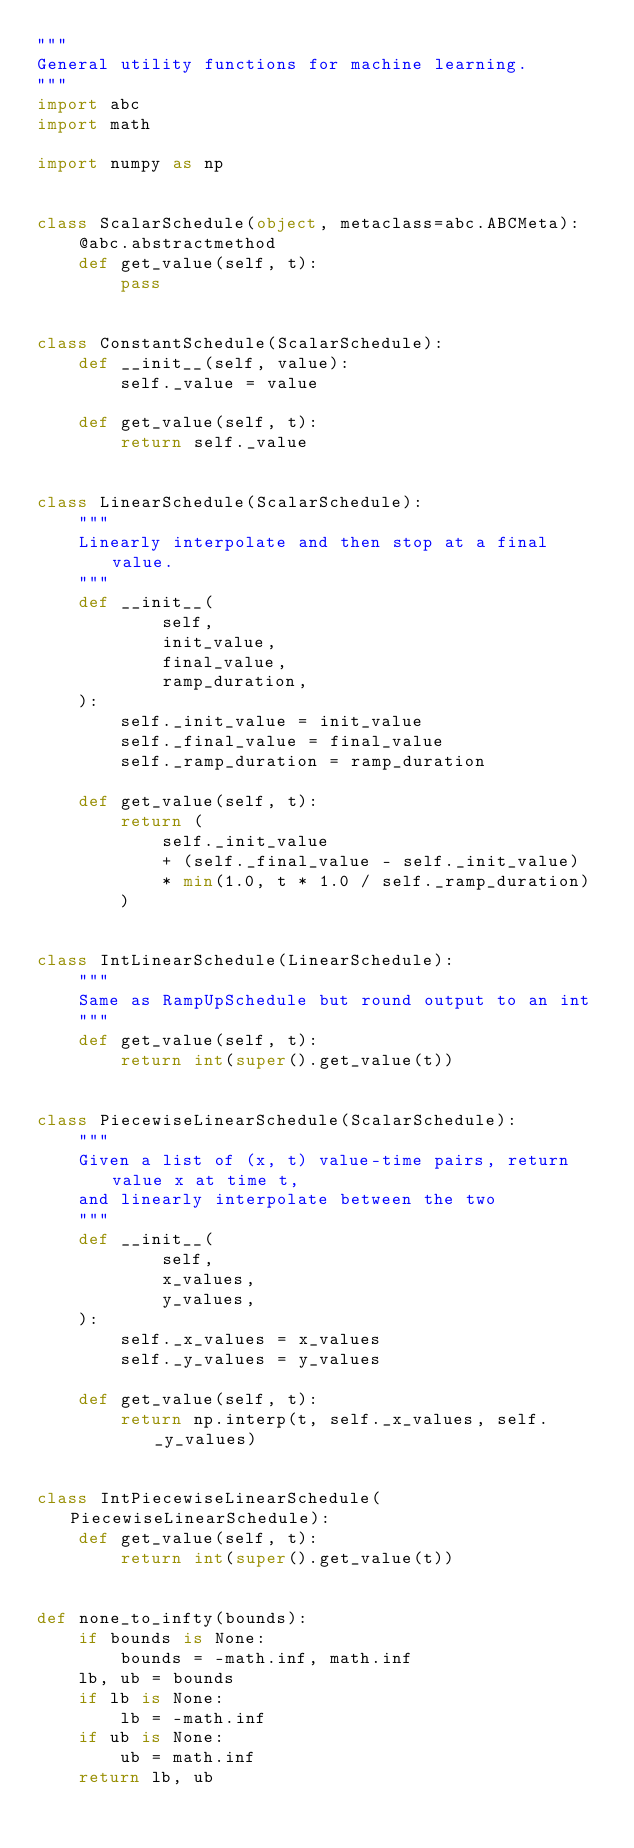<code> <loc_0><loc_0><loc_500><loc_500><_Python_>"""
General utility functions for machine learning.
"""
import abc
import math

import numpy as np


class ScalarSchedule(object, metaclass=abc.ABCMeta):
    @abc.abstractmethod
    def get_value(self, t):
        pass


class ConstantSchedule(ScalarSchedule):
    def __init__(self, value):
        self._value = value

    def get_value(self, t):
        return self._value


class LinearSchedule(ScalarSchedule):
    """
    Linearly interpolate and then stop at a final value.
    """
    def __init__(
            self,
            init_value,
            final_value,
            ramp_duration,
    ):
        self._init_value = init_value
        self._final_value = final_value
        self._ramp_duration = ramp_duration

    def get_value(self, t):
        return (
            self._init_value
            + (self._final_value - self._init_value)
            * min(1.0, t * 1.0 / self._ramp_duration)
        )


class IntLinearSchedule(LinearSchedule):
    """
    Same as RampUpSchedule but round output to an int
    """
    def get_value(self, t):
        return int(super().get_value(t))


class PiecewiseLinearSchedule(ScalarSchedule):
    """
    Given a list of (x, t) value-time pairs, return value x at time t,
    and linearly interpolate between the two
    """
    def __init__(
            self,
            x_values,
            y_values,
    ):
        self._x_values = x_values
        self._y_values = y_values

    def get_value(self, t):
        return np.interp(t, self._x_values, self._y_values)


class IntPiecewiseLinearSchedule(PiecewiseLinearSchedule):
    def get_value(self, t):
        return int(super().get_value(t))


def none_to_infty(bounds):
    if bounds is None:
        bounds = -math.inf, math.inf
    lb, ub = bounds
    if lb is None:
        lb = -math.inf
    if ub is None:
        ub = math.inf
    return lb, ub
</code> 